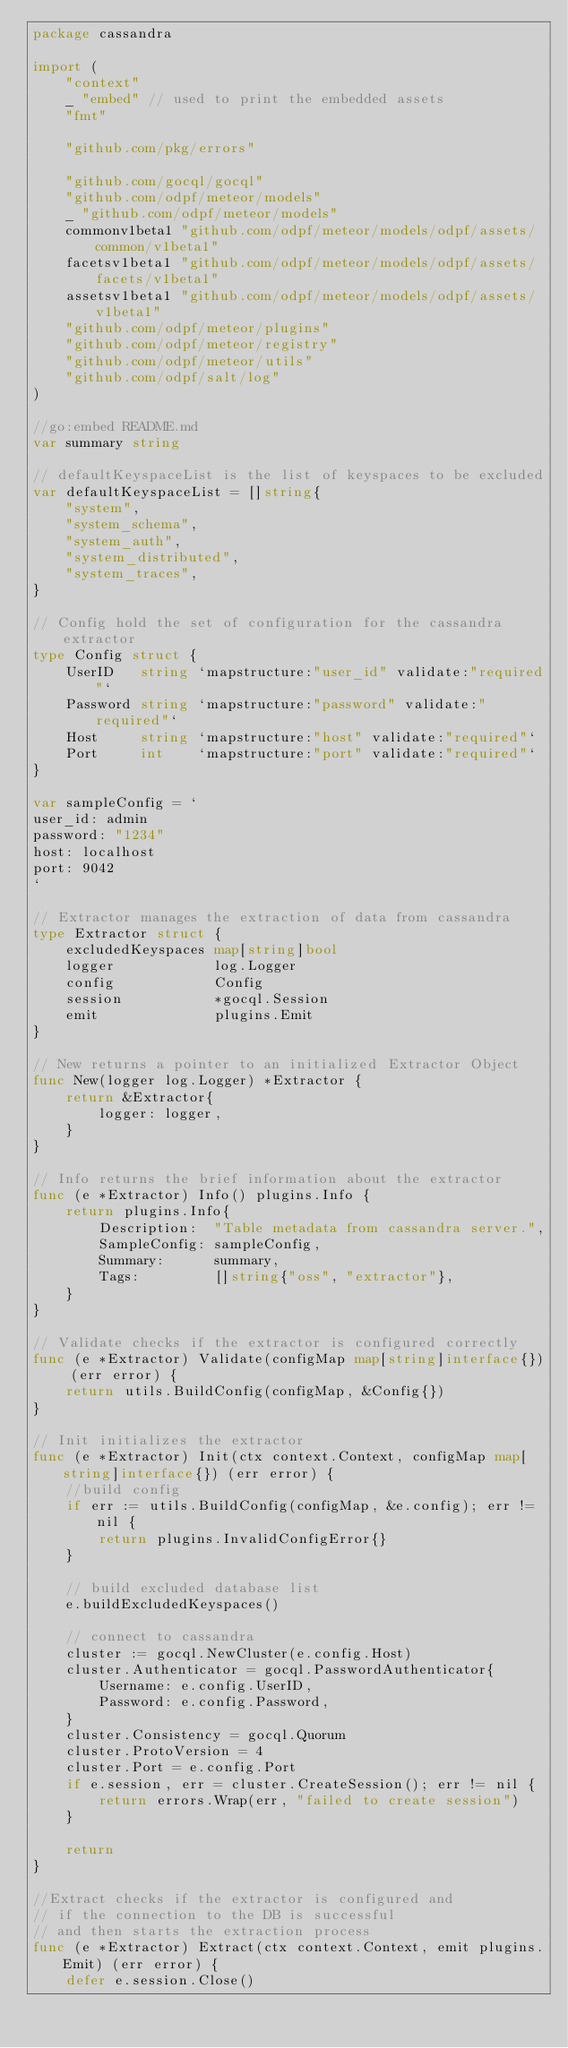Convert code to text. <code><loc_0><loc_0><loc_500><loc_500><_Go_>package cassandra

import (
	"context"
	_ "embed" // used to print the embedded assets
	"fmt"

	"github.com/pkg/errors"

	"github.com/gocql/gocql"
	"github.com/odpf/meteor/models"
	_ "github.com/odpf/meteor/models"
	commonv1beta1 "github.com/odpf/meteor/models/odpf/assets/common/v1beta1"
	facetsv1beta1 "github.com/odpf/meteor/models/odpf/assets/facets/v1beta1"
	assetsv1beta1 "github.com/odpf/meteor/models/odpf/assets/v1beta1"
	"github.com/odpf/meteor/plugins"
	"github.com/odpf/meteor/registry"
	"github.com/odpf/meteor/utils"
	"github.com/odpf/salt/log"
)

//go:embed README.md
var summary string

// defaultKeyspaceList is the list of keyspaces to be excluded
var defaultKeyspaceList = []string{
	"system",
	"system_schema",
	"system_auth",
	"system_distributed",
	"system_traces",
}

// Config hold the set of configuration for the cassandra extractor
type Config struct {
	UserID   string `mapstructure:"user_id" validate:"required"`
	Password string `mapstructure:"password" validate:"required"`
	Host     string `mapstructure:"host" validate:"required"`
	Port     int    `mapstructure:"port" validate:"required"`
}

var sampleConfig = `
user_id: admin
password: "1234"
host: localhost
port: 9042
`

// Extractor manages the extraction of data from cassandra
type Extractor struct {
	excludedKeyspaces map[string]bool
	logger            log.Logger
	config            Config
	session           *gocql.Session
	emit              plugins.Emit
}

// New returns a pointer to an initialized Extractor Object
func New(logger log.Logger) *Extractor {
	return &Extractor{
		logger: logger,
	}
}

// Info returns the brief information about the extractor
func (e *Extractor) Info() plugins.Info {
	return plugins.Info{
		Description:  "Table metadata from cassandra server.",
		SampleConfig: sampleConfig,
		Summary:      summary,
		Tags:         []string{"oss", "extractor"},
	}
}

// Validate checks if the extractor is configured correctly
func (e *Extractor) Validate(configMap map[string]interface{}) (err error) {
	return utils.BuildConfig(configMap, &Config{})
}

// Init initializes the extractor
func (e *Extractor) Init(ctx context.Context, configMap map[string]interface{}) (err error) {
	//build config
	if err := utils.BuildConfig(configMap, &e.config); err != nil {
		return plugins.InvalidConfigError{}
	}

	// build excluded database list
	e.buildExcludedKeyspaces()

	// connect to cassandra
	cluster := gocql.NewCluster(e.config.Host)
	cluster.Authenticator = gocql.PasswordAuthenticator{
		Username: e.config.UserID,
		Password: e.config.Password,
	}
	cluster.Consistency = gocql.Quorum
	cluster.ProtoVersion = 4
	cluster.Port = e.config.Port
	if e.session, err = cluster.CreateSession(); err != nil {
		return errors.Wrap(err, "failed to create session")
	}

	return
}

//Extract checks if the extractor is configured and
// if the connection to the DB is successful
// and then starts the extraction process
func (e *Extractor) Extract(ctx context.Context, emit plugins.Emit) (err error) {
	defer e.session.Close()</code> 